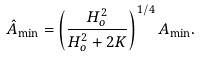Convert formula to latex. <formula><loc_0><loc_0><loc_500><loc_500>\hat { A } _ { \min } = \left ( \frac { H _ { o } ^ { 2 } } { H _ { o } ^ { 2 } + 2 K } \right ) ^ { 1 / 4 } A _ { \min } .</formula> 